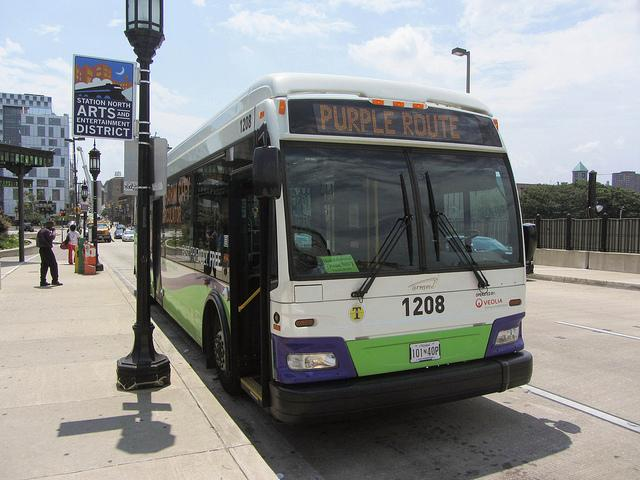What is the bus doing near the sidewalk?

Choices:
A) stopping
B) backing up
C) racing
D) accelerating stopping 